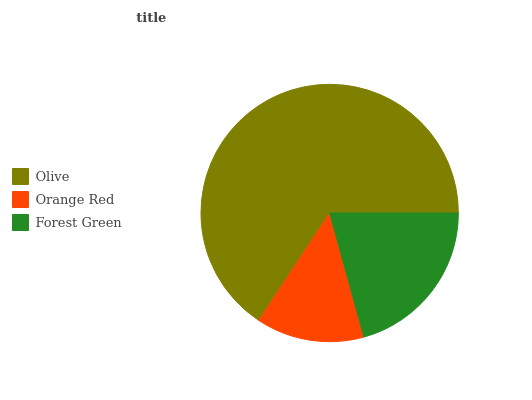Is Orange Red the minimum?
Answer yes or no. Yes. Is Olive the maximum?
Answer yes or no. Yes. Is Forest Green the minimum?
Answer yes or no. No. Is Forest Green the maximum?
Answer yes or no. No. Is Forest Green greater than Orange Red?
Answer yes or no. Yes. Is Orange Red less than Forest Green?
Answer yes or no. Yes. Is Orange Red greater than Forest Green?
Answer yes or no. No. Is Forest Green less than Orange Red?
Answer yes or no. No. Is Forest Green the high median?
Answer yes or no. Yes. Is Forest Green the low median?
Answer yes or no. Yes. Is Orange Red the high median?
Answer yes or no. No. Is Orange Red the low median?
Answer yes or no. No. 